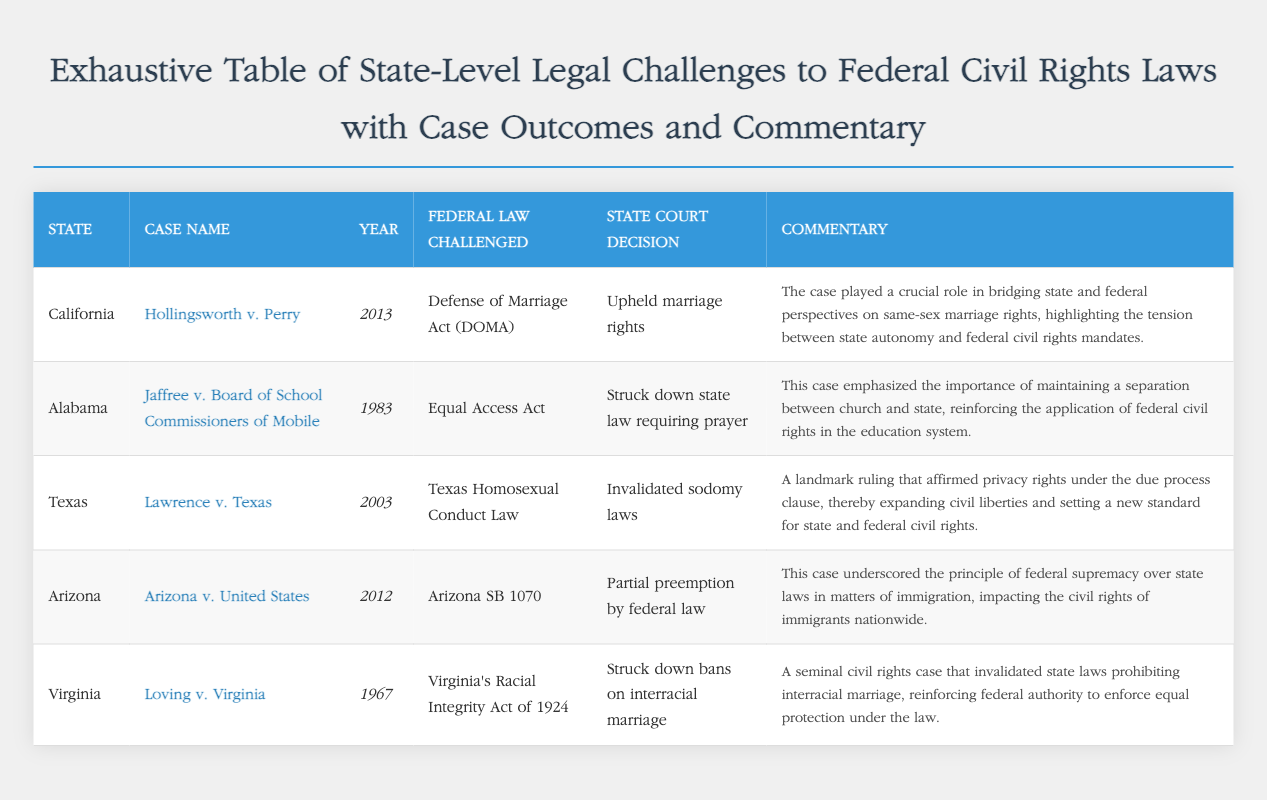What is the case name for California? The case name listed for California is "Hollingsworth v. Perry".
Answer: Hollingsworth v. Perry In which year was the "Hollingsworth v. Perry" case decided? The year of the "Hollingsworth v. Perry" case is found in the document as 2013.
Answer: 2013 What was the outcome of "Loving v. Virginia"? The document mentions that "Loving v. Virginia" resulted in the strikes down of bans on interracial marriage.
Answer: Struck down bans on interracial marriage Which federal law was challenged in "Lawrence v. Texas"? The federal law challenged in "Lawrence v. Texas" is the “Texas Homosexual Conduct Law”.
Answer: Texas Homosexual Conduct Law What state challenged the Equal Access Act? According to the document, Alabama challenged the Equal Access Act.
Answer: Alabama What commentary is provided about "Arizona v. United States"? The commentary mentions that the case underscored the principle of federal supremacy over state laws.
Answer: Underscored the principle of federal supremacy over state laws How many cases are listed in the document? The total number of cases listed in the document can be counted from the table, and there are five cases.
Answer: Five cases Which state had a case involving the Defense of Marriage Act? The state involved in a case with the Defense of Marriage Act is California.
Answer: California What type of legal cases does this document summarize? The document summarizes state-level legal challenges to federal civil rights laws.
Answer: State-level legal challenges to federal civil rights laws 